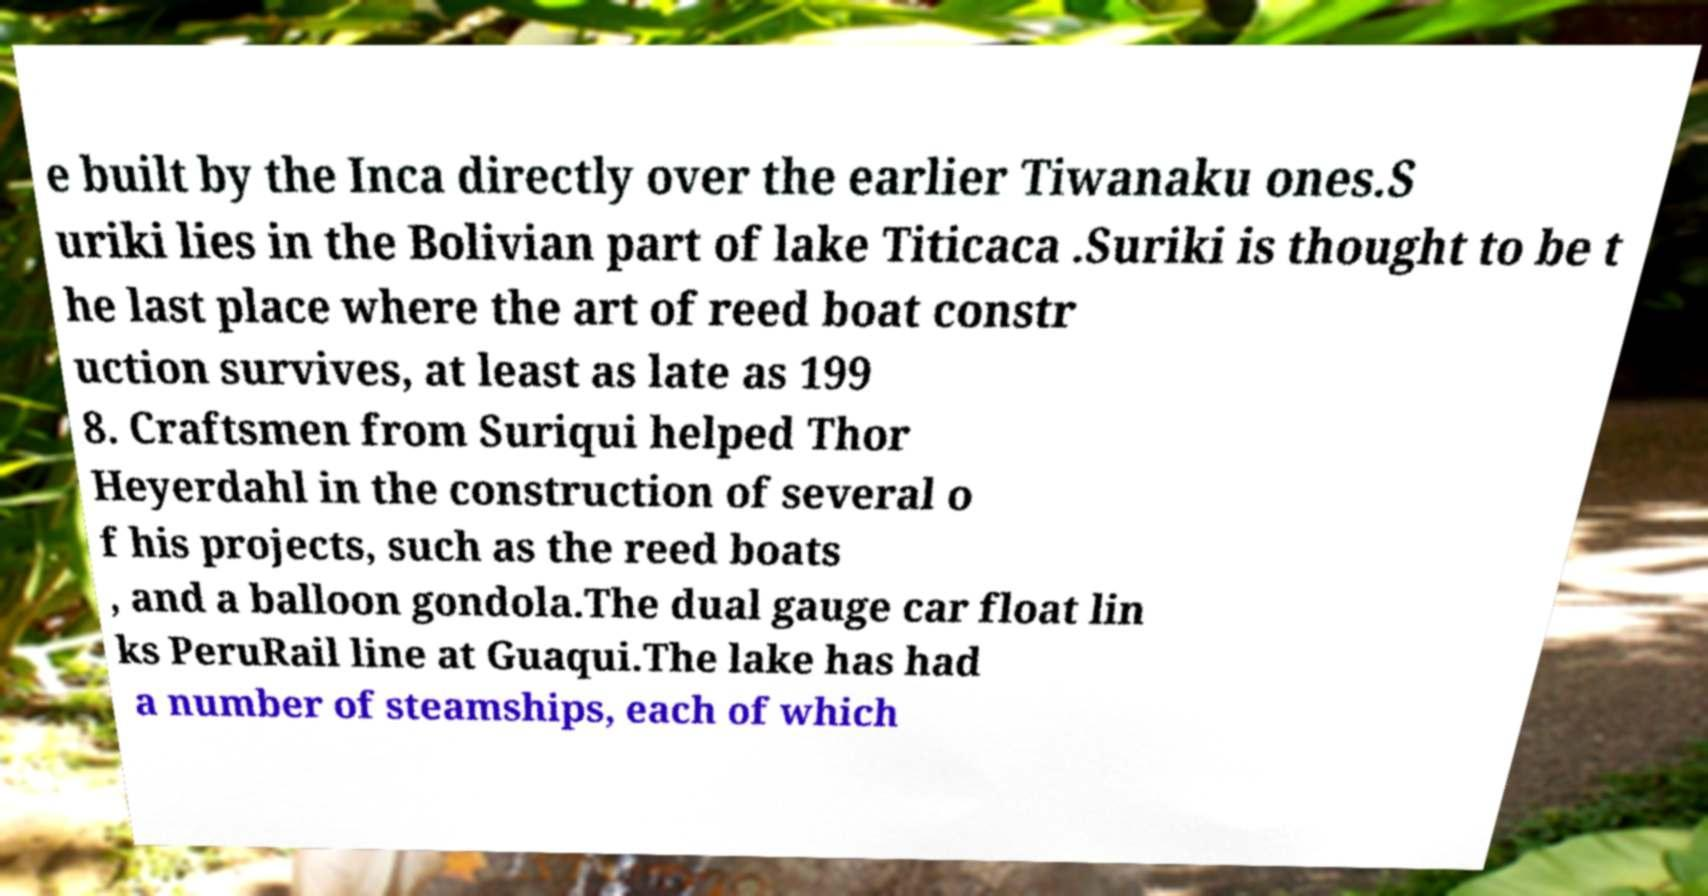Can you read and provide the text displayed in the image?This photo seems to have some interesting text. Can you extract and type it out for me? e built by the Inca directly over the earlier Tiwanaku ones.S uriki lies in the Bolivian part of lake Titicaca .Suriki is thought to be t he last place where the art of reed boat constr uction survives, at least as late as 199 8. Craftsmen from Suriqui helped Thor Heyerdahl in the construction of several o f his projects, such as the reed boats , and a balloon gondola.The dual gauge car float lin ks PeruRail line at Guaqui.The lake has had a number of steamships, each of which 